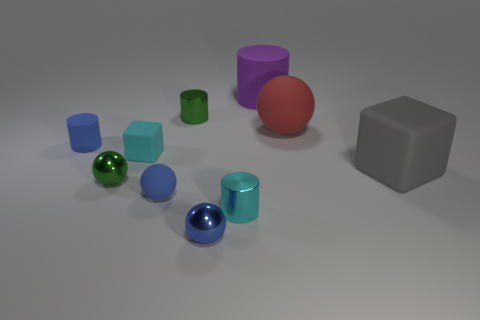There is a cyan metallic thing that is the same size as the blue metallic object; what shape is it?
Your answer should be compact. Cylinder. Is there any other thing that is made of the same material as the small block?
Your response must be concise. Yes. What number of objects are tiny cyan objects that are behind the large gray rubber object or large blocks?
Your response must be concise. 2. There is a big rubber sphere behind the small shiny cylinder that is in front of the blue cylinder; are there any big purple things that are in front of it?
Ensure brevity in your answer.  No. How many tiny cyan objects are there?
Offer a terse response. 2. What number of objects are small green things that are behind the large ball or rubber cubes that are on the right side of the red matte sphere?
Provide a short and direct response. 2. Is the size of the block that is to the left of the purple cylinder the same as the big red ball?
Give a very brief answer. No. What is the size of the other matte object that is the same shape as the tiny cyan rubber thing?
Keep it short and to the point. Large. There is a cyan thing that is the same size as the cyan rubber cube; what is it made of?
Offer a very short reply. Metal. There is a tiny blue thing that is the same shape as the big purple thing; what is its material?
Give a very brief answer. Rubber. 